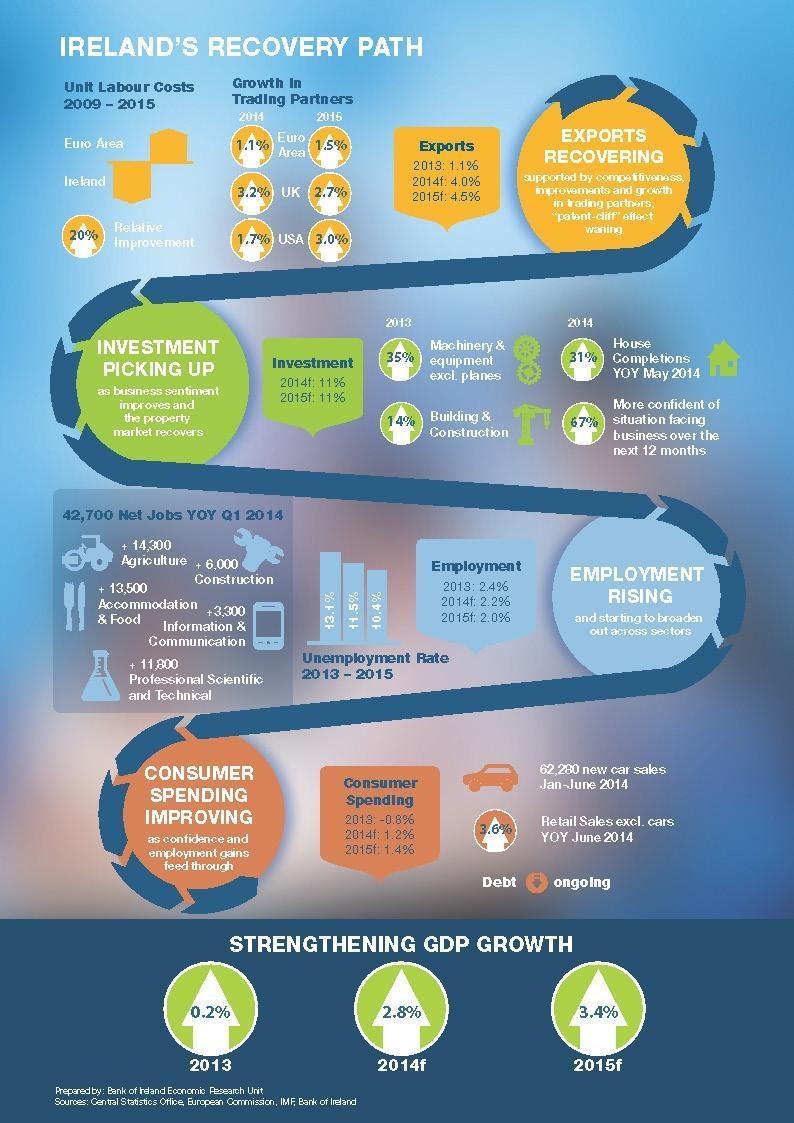In 2013, what increased by 35%?
Answer the question with a short phrase. Machinery & equipment excl. planes When was the unemployment rate highest? 2013 In 2015, which trading partner had higher percentage of recovery? USA By what percent did car sales go up? 3.6% What was the GDP growth in 2014? 2.8% 